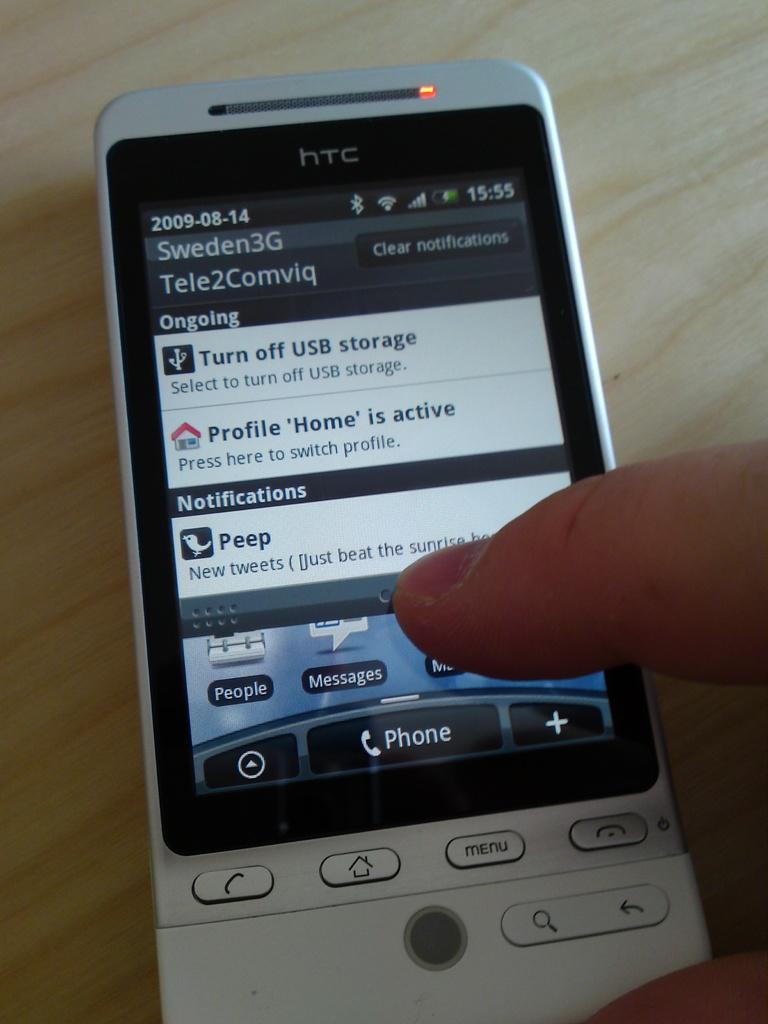<image>
Render a clear and concise summary of the photo. HTC cellphone with Sweden3G and notifications showing on screen. 